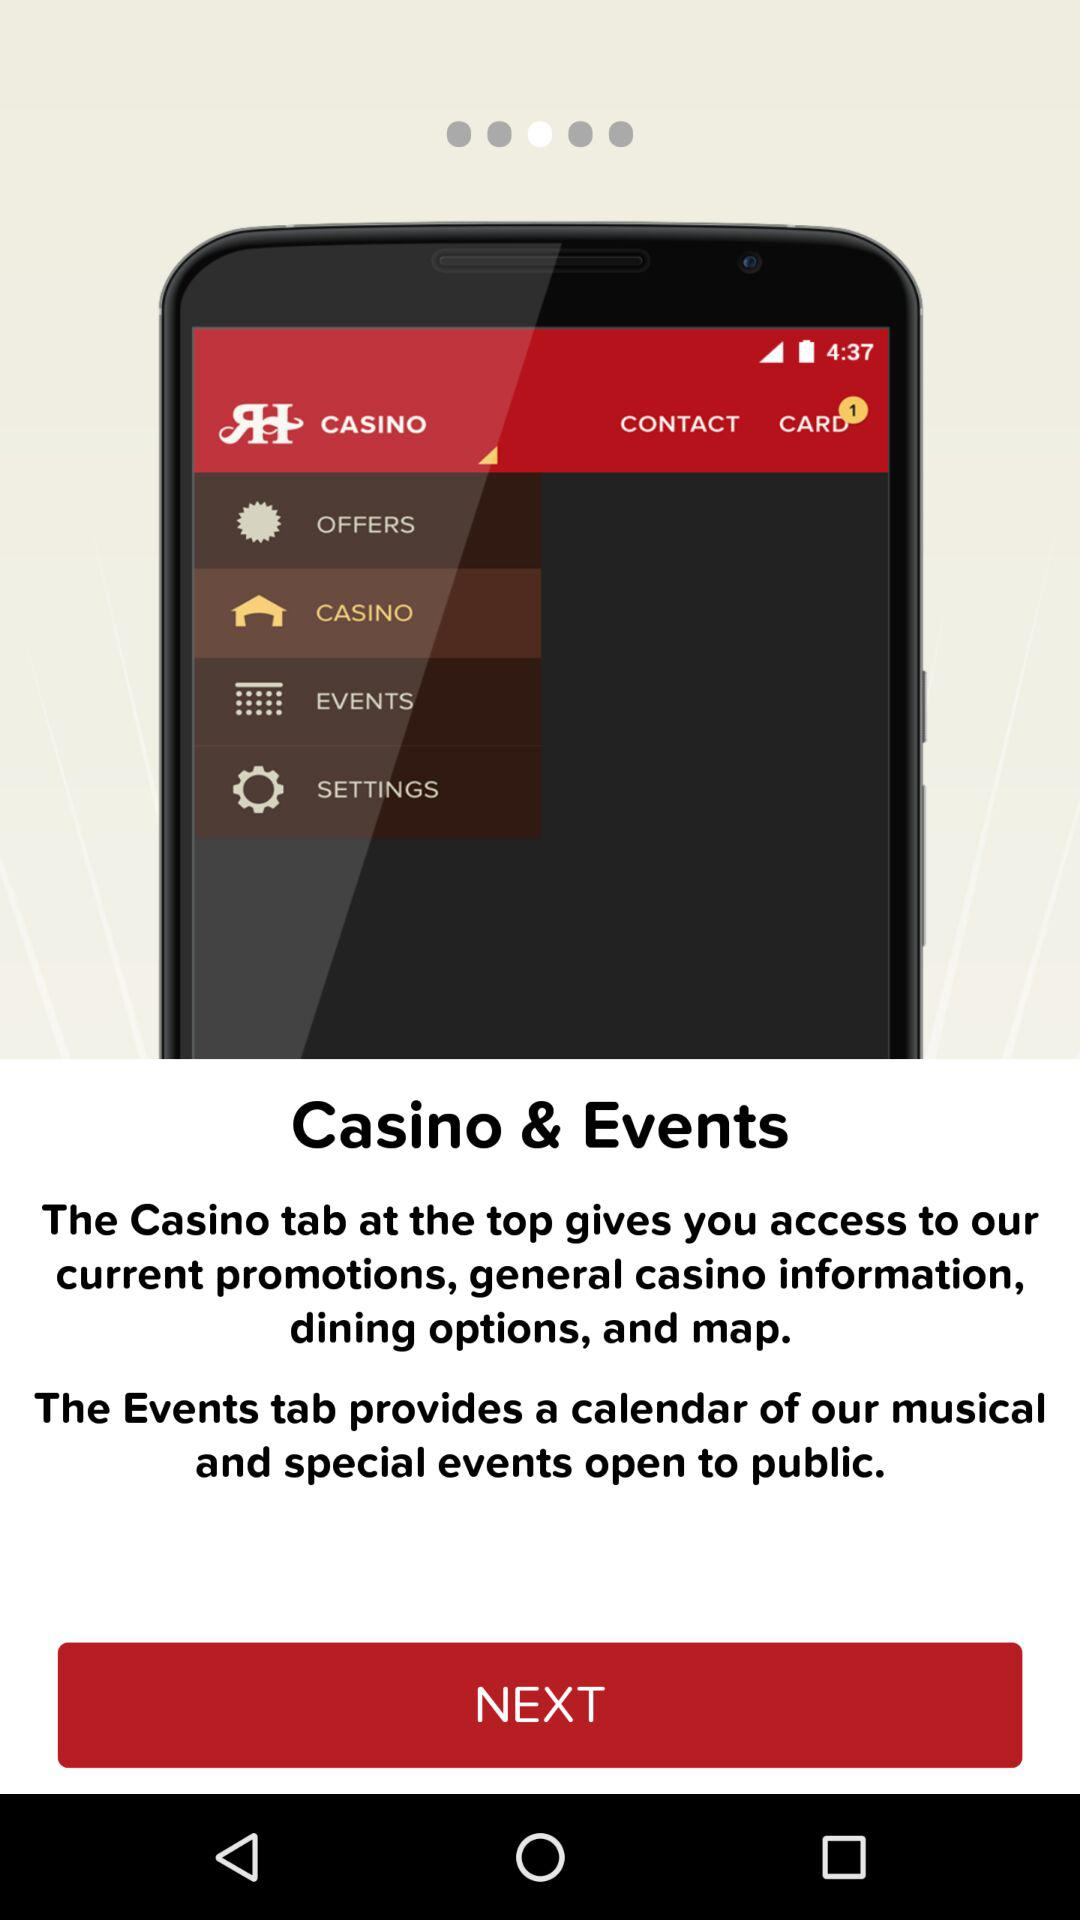How many notifications are pending in "CARD"? There is 1 notification pending in "CARD". 